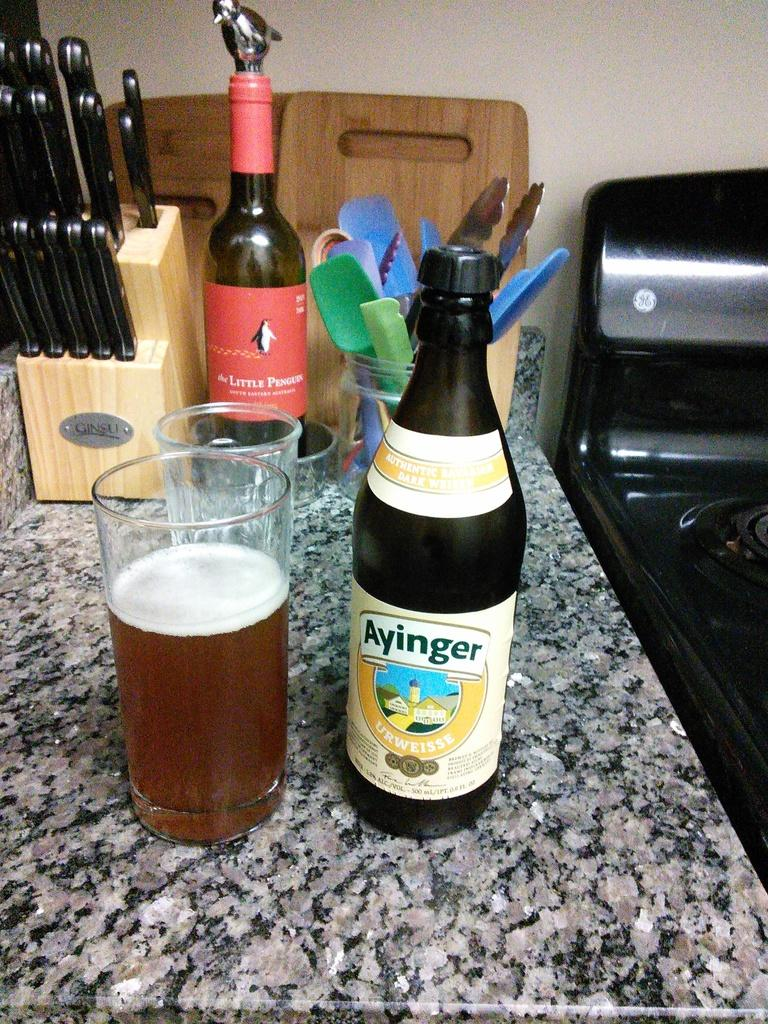Provide a one-sentence caption for the provided image. A bottle of Ayinger sits next to a glass filled with liquid. 